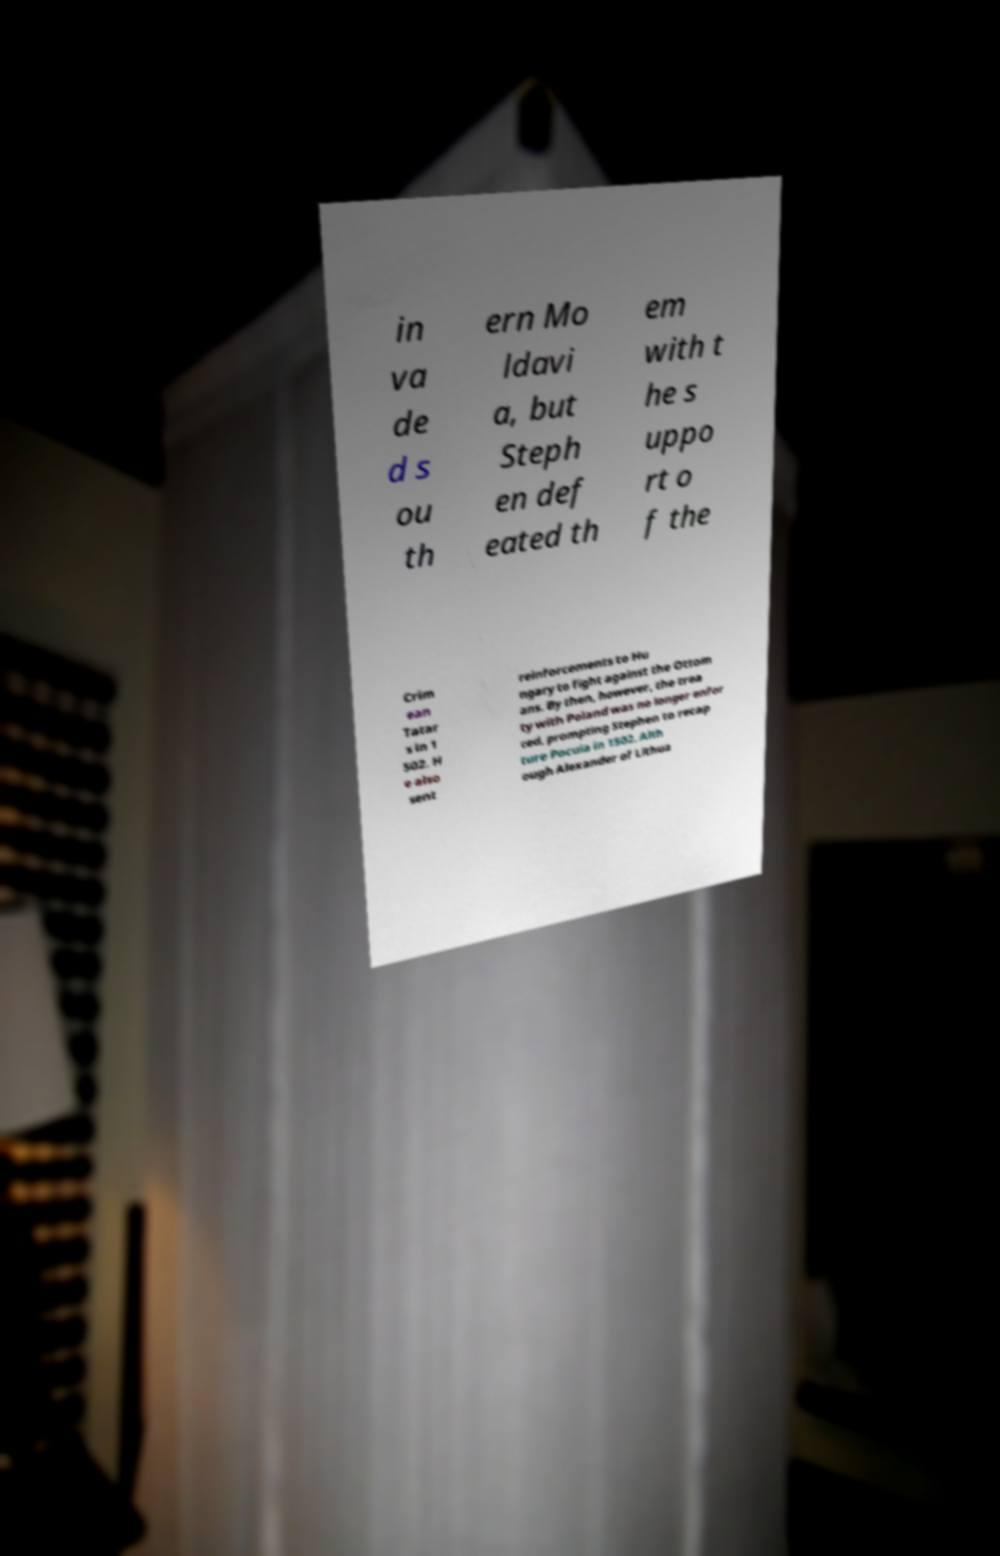Could you extract and type out the text from this image? in va de d s ou th ern Mo ldavi a, but Steph en def eated th em with t he s uppo rt o f the Crim ean Tatar s in 1 502. H e also sent reinforcements to Hu ngary to fight against the Ottom ans. By then, however, the trea ty with Poland was no longer enfor ced, prompting Stephen to recap ture Pocuia in 1502. Alth ough Alexander of Lithua 